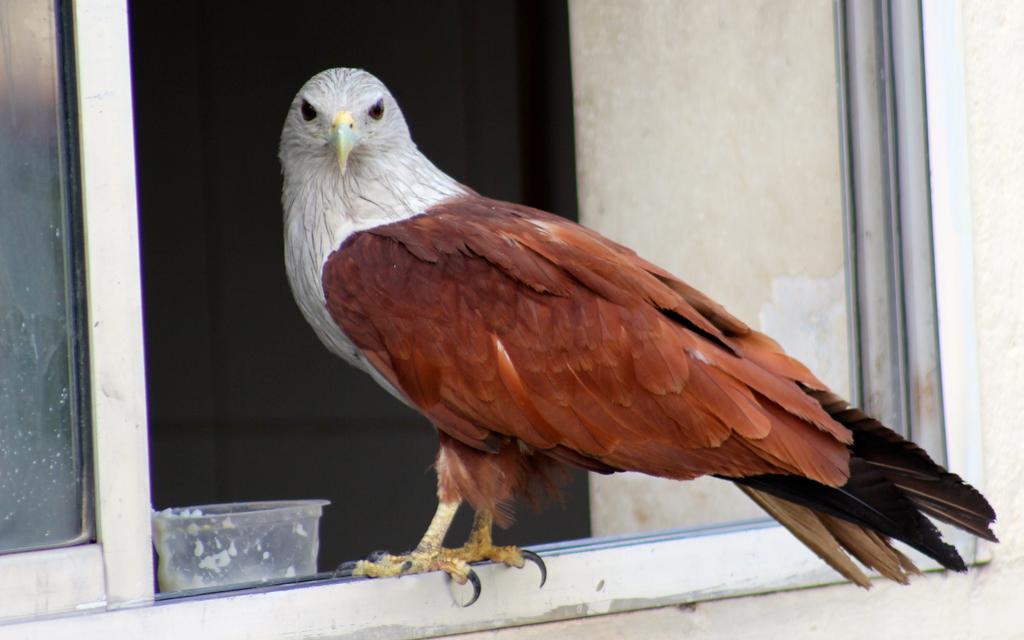What type of bird is in the image? There is an eagle in the image. Can you describe the colors of the eagle? The eagle has brown and white colors. What other object is visible in the image? There is a glass in the image. How many boys are playing with the card in the image? There are no boys or cards present in the image; it only features an eagle and a glass. 